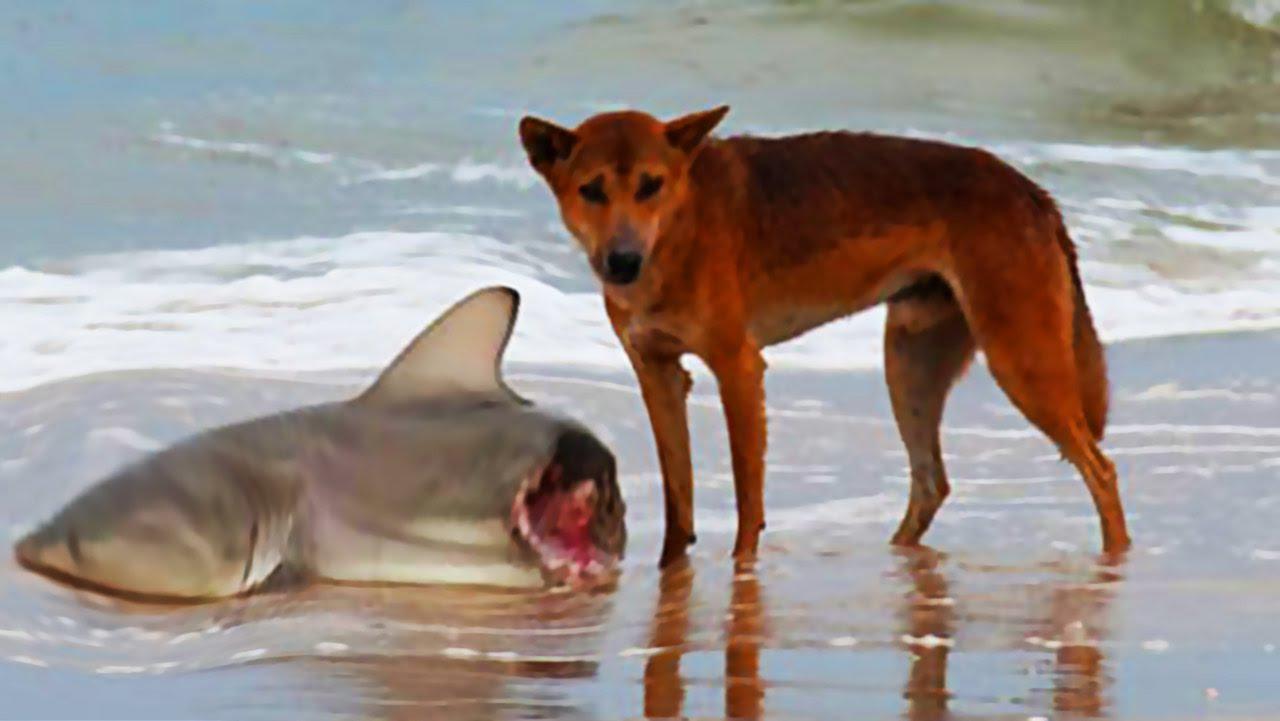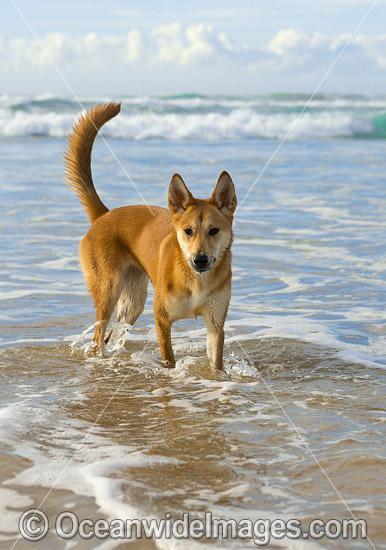The first image is the image on the left, the second image is the image on the right. Considering the images on both sides, is "At least one dog is in water, surrounded by water." valid? Answer yes or no. Yes. 